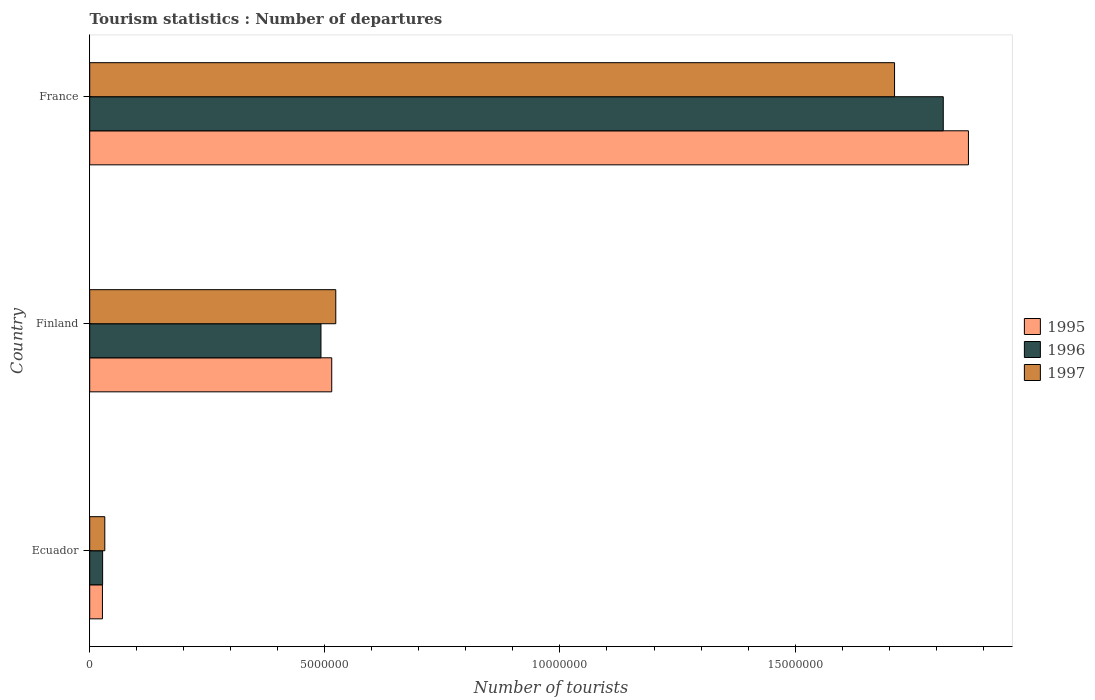How many different coloured bars are there?
Offer a very short reply. 3. How many groups of bars are there?
Your response must be concise. 3. Are the number of bars per tick equal to the number of legend labels?
Keep it short and to the point. Yes. Are the number of bars on each tick of the Y-axis equal?
Offer a terse response. Yes. How many bars are there on the 1st tick from the bottom?
Your answer should be very brief. 3. In how many cases, is the number of bars for a given country not equal to the number of legend labels?
Your answer should be compact. 0. What is the number of tourist departures in 1996 in Finland?
Offer a very short reply. 4.92e+06. Across all countries, what is the maximum number of tourist departures in 1996?
Offer a very short reply. 1.82e+07. Across all countries, what is the minimum number of tourist departures in 1996?
Provide a short and direct response. 2.75e+05. In which country was the number of tourist departures in 1997 maximum?
Ensure brevity in your answer.  France. In which country was the number of tourist departures in 1997 minimum?
Your response must be concise. Ecuador. What is the total number of tourist departures in 1996 in the graph?
Give a very brief answer. 2.33e+07. What is the difference between the number of tourist departures in 1997 in Ecuador and that in France?
Your answer should be very brief. -1.68e+07. What is the difference between the number of tourist departures in 1995 in Finland and the number of tourist departures in 1997 in Ecuador?
Your answer should be very brief. 4.83e+06. What is the average number of tourist departures in 1995 per country?
Provide a short and direct response. 8.03e+06. What is the difference between the number of tourist departures in 1995 and number of tourist departures in 1997 in Finland?
Offer a terse response. -8.60e+04. What is the ratio of the number of tourist departures in 1996 in Finland to that in France?
Your answer should be very brief. 0.27. Is the difference between the number of tourist departures in 1995 in Ecuador and France greater than the difference between the number of tourist departures in 1997 in Ecuador and France?
Give a very brief answer. No. What is the difference between the highest and the second highest number of tourist departures in 1997?
Keep it short and to the point. 1.19e+07. What is the difference between the highest and the lowest number of tourist departures in 1996?
Offer a very short reply. 1.79e+07. In how many countries, is the number of tourist departures in 1995 greater than the average number of tourist departures in 1995 taken over all countries?
Give a very brief answer. 1. Is the sum of the number of tourist departures in 1996 in Finland and France greater than the maximum number of tourist departures in 1995 across all countries?
Provide a succinct answer. Yes. What does the 2nd bar from the top in France represents?
Offer a terse response. 1996. Is it the case that in every country, the sum of the number of tourist departures in 1995 and number of tourist departures in 1996 is greater than the number of tourist departures in 1997?
Your answer should be compact. Yes. How many bars are there?
Ensure brevity in your answer.  9. Are all the bars in the graph horizontal?
Offer a terse response. Yes. How many countries are there in the graph?
Your answer should be very brief. 3. Are the values on the major ticks of X-axis written in scientific E-notation?
Provide a short and direct response. No. Does the graph contain any zero values?
Provide a succinct answer. No. How many legend labels are there?
Ensure brevity in your answer.  3. What is the title of the graph?
Offer a very short reply. Tourism statistics : Number of departures. Does "2001" appear as one of the legend labels in the graph?
Your answer should be compact. No. What is the label or title of the X-axis?
Your response must be concise. Number of tourists. What is the Number of tourists of 1995 in Ecuador?
Provide a short and direct response. 2.71e+05. What is the Number of tourists in 1996 in Ecuador?
Offer a very short reply. 2.75e+05. What is the Number of tourists of 1997 in Ecuador?
Give a very brief answer. 3.21e+05. What is the Number of tourists of 1995 in Finland?
Make the answer very short. 5.15e+06. What is the Number of tourists of 1996 in Finland?
Ensure brevity in your answer.  4.92e+06. What is the Number of tourists of 1997 in Finland?
Your answer should be very brief. 5.23e+06. What is the Number of tourists of 1995 in France?
Give a very brief answer. 1.87e+07. What is the Number of tourists of 1996 in France?
Your answer should be very brief. 1.82e+07. What is the Number of tourists of 1997 in France?
Give a very brief answer. 1.71e+07. Across all countries, what is the maximum Number of tourists of 1995?
Your response must be concise. 1.87e+07. Across all countries, what is the maximum Number of tourists in 1996?
Provide a short and direct response. 1.82e+07. Across all countries, what is the maximum Number of tourists of 1997?
Keep it short and to the point. 1.71e+07. Across all countries, what is the minimum Number of tourists in 1995?
Offer a very short reply. 2.71e+05. Across all countries, what is the minimum Number of tourists in 1996?
Offer a very short reply. 2.75e+05. Across all countries, what is the minimum Number of tourists of 1997?
Offer a terse response. 3.21e+05. What is the total Number of tourists in 1995 in the graph?
Your answer should be compact. 2.41e+07. What is the total Number of tourists of 1996 in the graph?
Provide a short and direct response. 2.33e+07. What is the total Number of tourists of 1997 in the graph?
Ensure brevity in your answer.  2.27e+07. What is the difference between the Number of tourists of 1995 in Ecuador and that in Finland?
Offer a terse response. -4.88e+06. What is the difference between the Number of tourists of 1996 in Ecuador and that in Finland?
Your answer should be very brief. -4.64e+06. What is the difference between the Number of tourists of 1997 in Ecuador and that in Finland?
Keep it short and to the point. -4.91e+06. What is the difference between the Number of tourists in 1995 in Ecuador and that in France?
Give a very brief answer. -1.84e+07. What is the difference between the Number of tourists of 1996 in Ecuador and that in France?
Provide a short and direct response. -1.79e+07. What is the difference between the Number of tourists of 1997 in Ecuador and that in France?
Provide a short and direct response. -1.68e+07. What is the difference between the Number of tourists of 1995 in Finland and that in France?
Offer a very short reply. -1.35e+07. What is the difference between the Number of tourists of 1996 in Finland and that in France?
Your answer should be very brief. -1.32e+07. What is the difference between the Number of tourists in 1997 in Finland and that in France?
Offer a very short reply. -1.19e+07. What is the difference between the Number of tourists in 1995 in Ecuador and the Number of tourists in 1996 in Finland?
Keep it short and to the point. -4.65e+06. What is the difference between the Number of tourists in 1995 in Ecuador and the Number of tourists in 1997 in Finland?
Offer a very short reply. -4.96e+06. What is the difference between the Number of tourists of 1996 in Ecuador and the Number of tourists of 1997 in Finland?
Offer a terse response. -4.96e+06. What is the difference between the Number of tourists of 1995 in Ecuador and the Number of tourists of 1996 in France?
Offer a very short reply. -1.79e+07. What is the difference between the Number of tourists of 1995 in Ecuador and the Number of tourists of 1997 in France?
Offer a terse response. -1.68e+07. What is the difference between the Number of tourists in 1996 in Ecuador and the Number of tourists in 1997 in France?
Keep it short and to the point. -1.68e+07. What is the difference between the Number of tourists in 1995 in Finland and the Number of tourists in 1996 in France?
Your response must be concise. -1.30e+07. What is the difference between the Number of tourists in 1995 in Finland and the Number of tourists in 1997 in France?
Provide a short and direct response. -1.20e+07. What is the difference between the Number of tourists of 1996 in Finland and the Number of tourists of 1997 in France?
Your response must be concise. -1.22e+07. What is the average Number of tourists of 1995 per country?
Provide a short and direct response. 8.03e+06. What is the average Number of tourists of 1996 per country?
Offer a terse response. 7.78e+06. What is the average Number of tourists in 1997 per country?
Provide a short and direct response. 7.56e+06. What is the difference between the Number of tourists in 1995 and Number of tourists in 1996 in Ecuador?
Provide a succinct answer. -4000. What is the difference between the Number of tourists of 1996 and Number of tourists of 1997 in Ecuador?
Your response must be concise. -4.60e+04. What is the difference between the Number of tourists of 1995 and Number of tourists of 1996 in Finland?
Provide a short and direct response. 2.29e+05. What is the difference between the Number of tourists in 1995 and Number of tourists in 1997 in Finland?
Your response must be concise. -8.60e+04. What is the difference between the Number of tourists of 1996 and Number of tourists of 1997 in Finland?
Keep it short and to the point. -3.15e+05. What is the difference between the Number of tourists in 1995 and Number of tourists in 1996 in France?
Offer a terse response. 5.35e+05. What is the difference between the Number of tourists in 1995 and Number of tourists in 1997 in France?
Your response must be concise. 1.57e+06. What is the difference between the Number of tourists in 1996 and Number of tourists in 1997 in France?
Your answer should be very brief. 1.04e+06. What is the ratio of the Number of tourists in 1995 in Ecuador to that in Finland?
Provide a succinct answer. 0.05. What is the ratio of the Number of tourists of 1996 in Ecuador to that in Finland?
Provide a short and direct response. 0.06. What is the ratio of the Number of tourists of 1997 in Ecuador to that in Finland?
Keep it short and to the point. 0.06. What is the ratio of the Number of tourists of 1995 in Ecuador to that in France?
Offer a very short reply. 0.01. What is the ratio of the Number of tourists of 1996 in Ecuador to that in France?
Offer a very short reply. 0.02. What is the ratio of the Number of tourists in 1997 in Ecuador to that in France?
Provide a short and direct response. 0.02. What is the ratio of the Number of tourists in 1995 in Finland to that in France?
Make the answer very short. 0.28. What is the ratio of the Number of tourists in 1996 in Finland to that in France?
Offer a terse response. 0.27. What is the ratio of the Number of tourists of 1997 in Finland to that in France?
Your answer should be very brief. 0.31. What is the difference between the highest and the second highest Number of tourists of 1995?
Provide a short and direct response. 1.35e+07. What is the difference between the highest and the second highest Number of tourists of 1996?
Provide a succinct answer. 1.32e+07. What is the difference between the highest and the second highest Number of tourists in 1997?
Provide a succinct answer. 1.19e+07. What is the difference between the highest and the lowest Number of tourists in 1995?
Ensure brevity in your answer.  1.84e+07. What is the difference between the highest and the lowest Number of tourists of 1996?
Provide a short and direct response. 1.79e+07. What is the difference between the highest and the lowest Number of tourists of 1997?
Your answer should be very brief. 1.68e+07. 